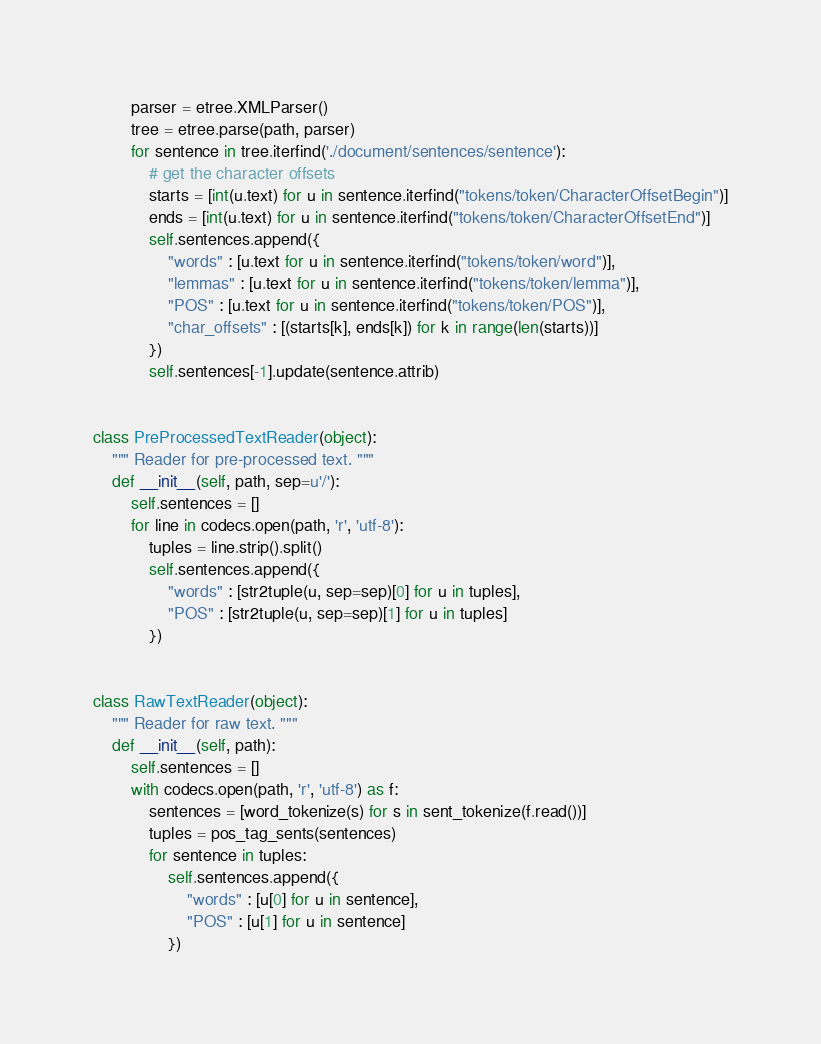<code> <loc_0><loc_0><loc_500><loc_500><_Python_>        parser = etree.XMLParser()
        tree = etree.parse(path, parser)
        for sentence in tree.iterfind('./document/sentences/sentence'):
            # get the character offsets
            starts = [int(u.text) for u in sentence.iterfind("tokens/token/CharacterOffsetBegin")]
            ends = [int(u.text) for u in sentence.iterfind("tokens/token/CharacterOffsetEnd")]
            self.sentences.append({
                "words" : [u.text for u in sentence.iterfind("tokens/token/word")],
                "lemmas" : [u.text for u in sentence.iterfind("tokens/token/lemma")],
                "POS" : [u.text for u in sentence.iterfind("tokens/token/POS")],
                "char_offsets" : [(starts[k], ends[k]) for k in range(len(starts))]
            })
            self.sentences[-1].update(sentence.attrib)


class PreProcessedTextReader(object):
    """ Reader for pre-processed text. """
    def __init__(self, path, sep=u'/'):
        self.sentences = []
        for line in codecs.open(path, 'r', 'utf-8'):
            tuples = line.strip().split()
            self.sentences.append({
                "words" : [str2tuple(u, sep=sep)[0] for u in tuples],
                "POS" : [str2tuple(u, sep=sep)[1] for u in tuples]
            })


class RawTextReader(object):
    """ Reader for raw text. """
    def __init__(self, path):
        self.sentences = []
        with codecs.open(path, 'r', 'utf-8') as f:
            sentences = [word_tokenize(s) for s in sent_tokenize(f.read())]
            tuples = pos_tag_sents(sentences)
            for sentence in tuples:
                self.sentences.append({
                    "words" : [u[0] for u in sentence],
                    "POS" : [u[1] for u in sentence]
                })
</code> 